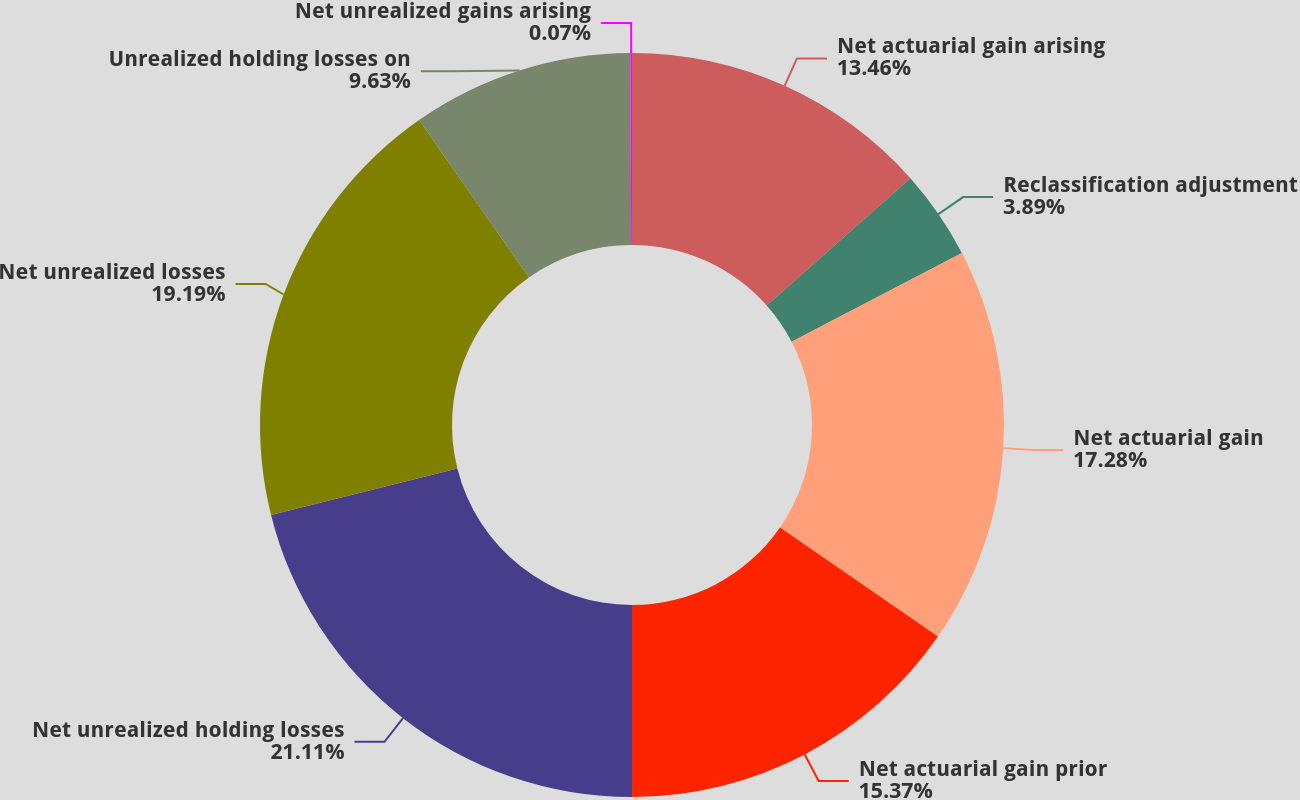Convert chart to OTSL. <chart><loc_0><loc_0><loc_500><loc_500><pie_chart><fcel>Net actuarial gain arising<fcel>Reclassification adjustment<fcel>Net actuarial gain<fcel>Net actuarial gain prior<fcel>Net unrealized holding losses<fcel>Net unrealized losses<fcel>Unrealized holding losses on<fcel>Net unrealized gains arising<nl><fcel>13.46%<fcel>3.89%<fcel>17.28%<fcel>15.37%<fcel>21.11%<fcel>19.19%<fcel>9.63%<fcel>0.07%<nl></chart> 